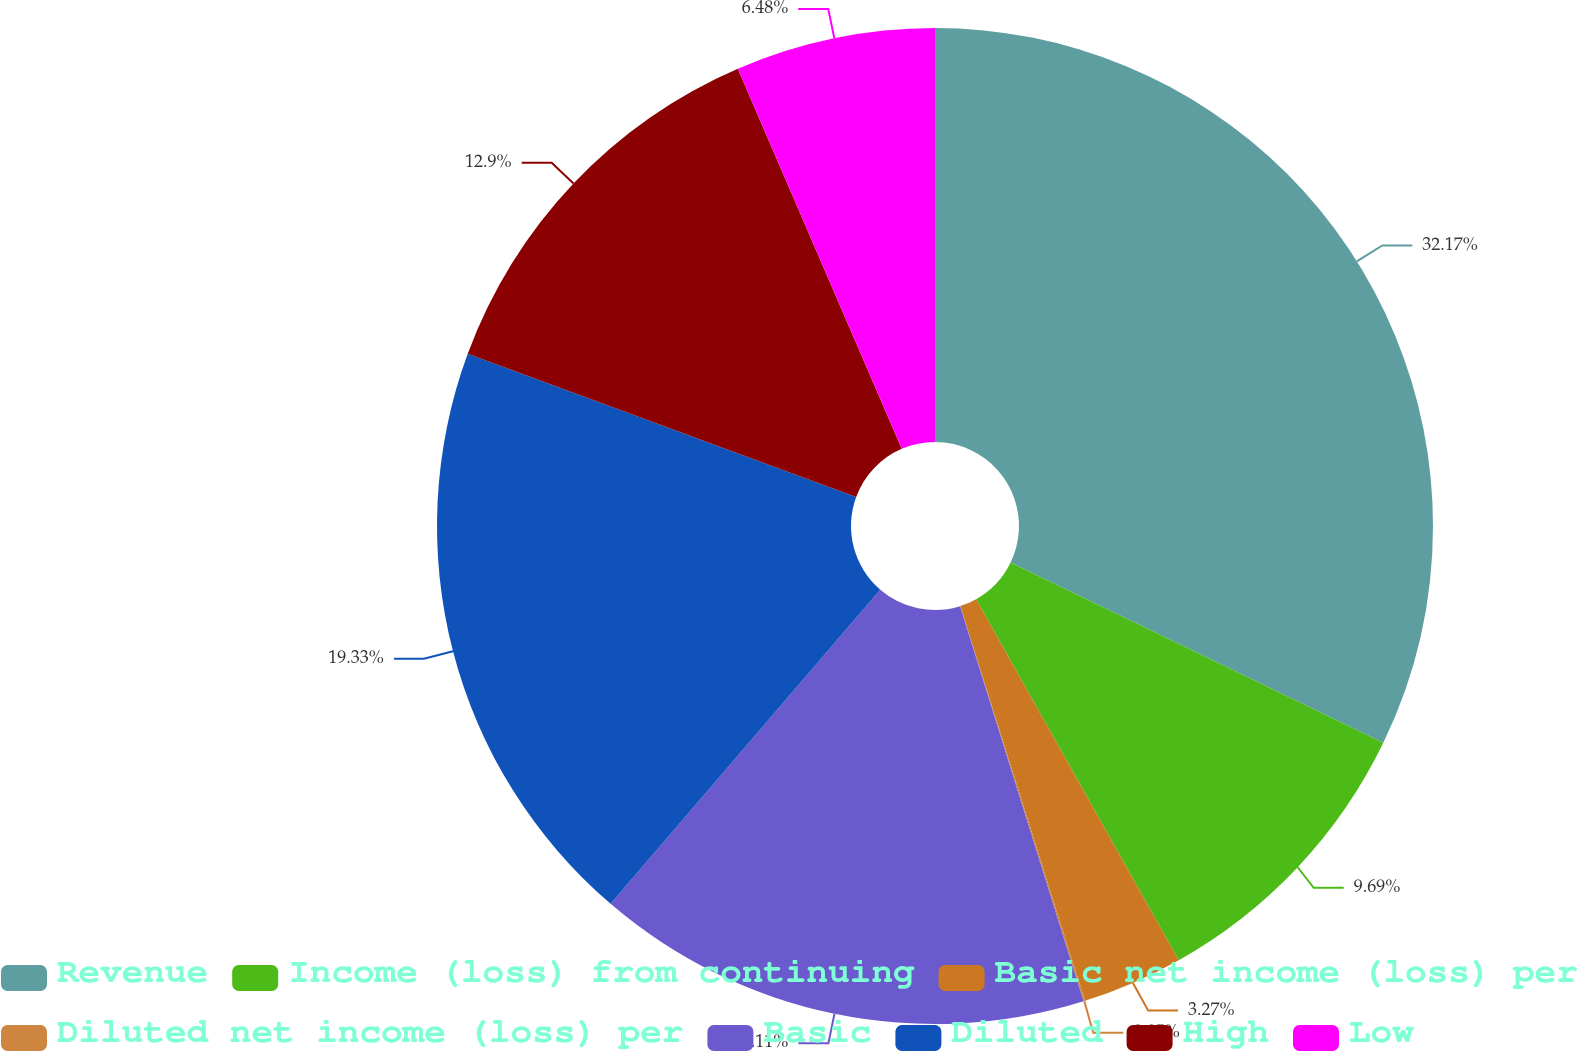Convert chart. <chart><loc_0><loc_0><loc_500><loc_500><pie_chart><fcel>Revenue<fcel>Income (loss) from continuing<fcel>Basic net income (loss) per<fcel>Diluted net income (loss) per<fcel>Basic<fcel>Diluted<fcel>High<fcel>Low<nl><fcel>32.17%<fcel>9.69%<fcel>3.27%<fcel>0.05%<fcel>16.11%<fcel>19.33%<fcel>12.9%<fcel>6.48%<nl></chart> 